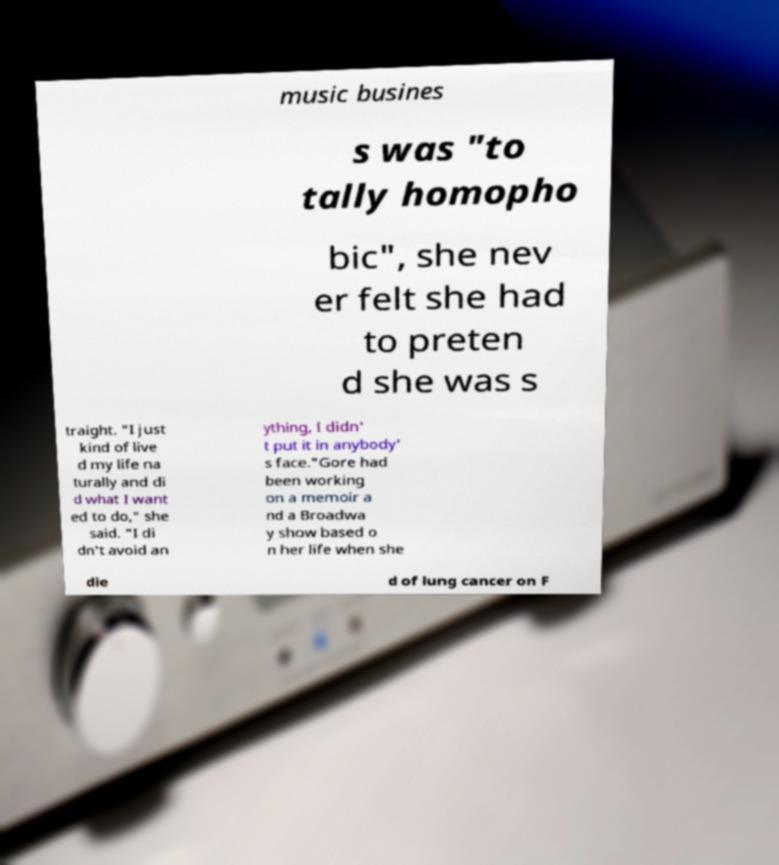There's text embedded in this image that I need extracted. Can you transcribe it verbatim? music busines s was "to tally homopho bic", she nev er felt she had to preten d she was s traight. "I just kind of live d my life na turally and di d what I want ed to do," she said. "I di dn't avoid an ything, I didn' t put it in anybody' s face."Gore had been working on a memoir a nd a Broadwa y show based o n her life when she die d of lung cancer on F 